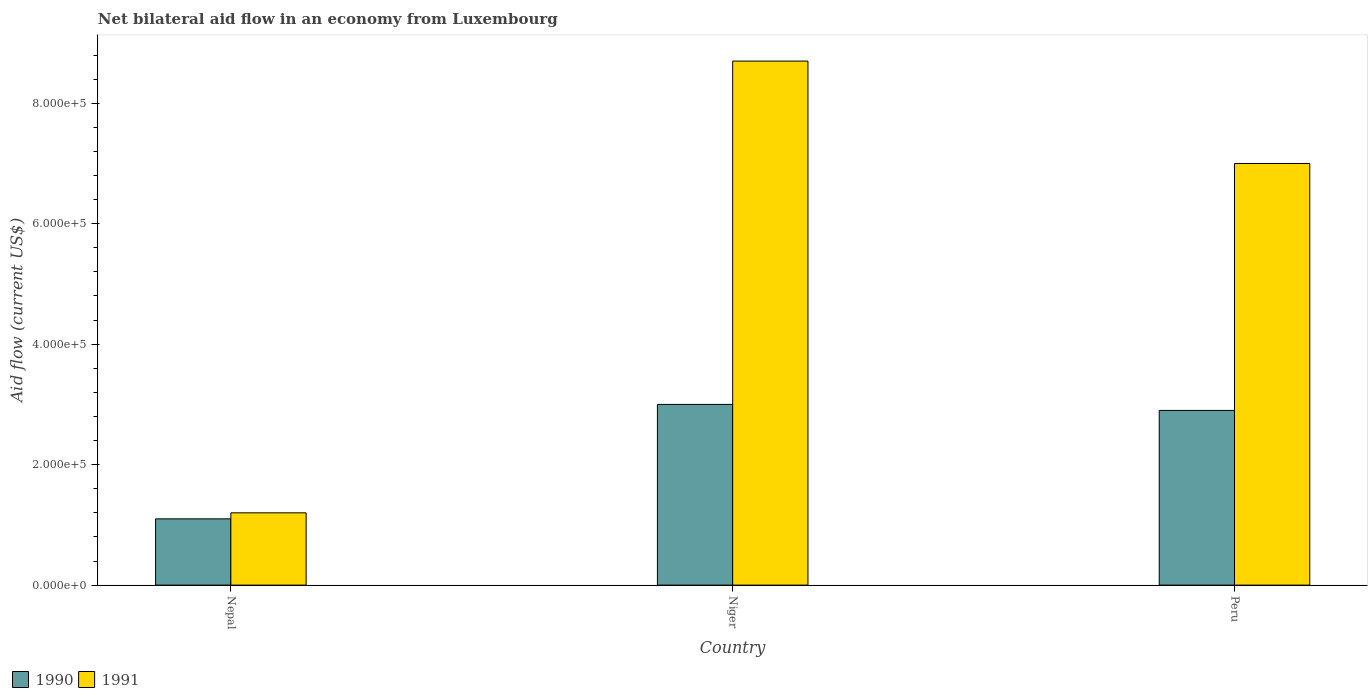How many different coloured bars are there?
Provide a succinct answer. 2. Are the number of bars per tick equal to the number of legend labels?
Give a very brief answer. Yes. How many bars are there on the 1st tick from the left?
Offer a terse response. 2. What is the label of the 2nd group of bars from the left?
Make the answer very short. Niger. What is the net bilateral aid flow in 1991 in Niger?
Keep it short and to the point. 8.70e+05. Across all countries, what is the maximum net bilateral aid flow in 1991?
Make the answer very short. 8.70e+05. Across all countries, what is the minimum net bilateral aid flow in 1991?
Your answer should be very brief. 1.20e+05. In which country was the net bilateral aid flow in 1991 maximum?
Ensure brevity in your answer.  Niger. In which country was the net bilateral aid flow in 1990 minimum?
Offer a very short reply. Nepal. What is the total net bilateral aid flow in 1991 in the graph?
Offer a terse response. 1.69e+06. What is the average net bilateral aid flow in 1990 per country?
Your response must be concise. 2.33e+05. What is the difference between the net bilateral aid flow of/in 1991 and net bilateral aid flow of/in 1990 in Peru?
Offer a terse response. 4.10e+05. What is the ratio of the net bilateral aid flow in 1990 in Nepal to that in Niger?
Keep it short and to the point. 0.37. Is the net bilateral aid flow in 1991 in Niger less than that in Peru?
Give a very brief answer. No. Is the difference between the net bilateral aid flow in 1991 in Nepal and Peru greater than the difference between the net bilateral aid flow in 1990 in Nepal and Peru?
Make the answer very short. No. What is the difference between the highest and the second highest net bilateral aid flow in 1990?
Provide a succinct answer. 1.90e+05. What is the difference between the highest and the lowest net bilateral aid flow in 1991?
Ensure brevity in your answer.  7.50e+05. Is the sum of the net bilateral aid flow in 1990 in Nepal and Niger greater than the maximum net bilateral aid flow in 1991 across all countries?
Offer a terse response. No. How many bars are there?
Ensure brevity in your answer.  6. Are all the bars in the graph horizontal?
Provide a short and direct response. No. How many countries are there in the graph?
Give a very brief answer. 3. What is the difference between two consecutive major ticks on the Y-axis?
Offer a terse response. 2.00e+05. Does the graph contain any zero values?
Your answer should be compact. No. Does the graph contain grids?
Ensure brevity in your answer.  No. What is the title of the graph?
Provide a short and direct response. Net bilateral aid flow in an economy from Luxembourg. What is the label or title of the Y-axis?
Provide a succinct answer. Aid flow (current US$). What is the Aid flow (current US$) in 1990 in Nepal?
Offer a terse response. 1.10e+05. What is the Aid flow (current US$) in 1991 in Nepal?
Your answer should be very brief. 1.20e+05. What is the Aid flow (current US$) of 1990 in Niger?
Give a very brief answer. 3.00e+05. What is the Aid flow (current US$) of 1991 in Niger?
Your answer should be compact. 8.70e+05. What is the Aid flow (current US$) of 1991 in Peru?
Your answer should be very brief. 7.00e+05. Across all countries, what is the maximum Aid flow (current US$) in 1991?
Keep it short and to the point. 8.70e+05. Across all countries, what is the minimum Aid flow (current US$) in 1990?
Keep it short and to the point. 1.10e+05. What is the total Aid flow (current US$) of 1991 in the graph?
Your answer should be very brief. 1.69e+06. What is the difference between the Aid flow (current US$) of 1991 in Nepal and that in Niger?
Provide a short and direct response. -7.50e+05. What is the difference between the Aid flow (current US$) in 1991 in Nepal and that in Peru?
Provide a short and direct response. -5.80e+05. What is the difference between the Aid flow (current US$) of 1990 in Niger and that in Peru?
Your answer should be compact. 10000. What is the difference between the Aid flow (current US$) of 1990 in Nepal and the Aid flow (current US$) of 1991 in Niger?
Your response must be concise. -7.60e+05. What is the difference between the Aid flow (current US$) of 1990 in Nepal and the Aid flow (current US$) of 1991 in Peru?
Keep it short and to the point. -5.90e+05. What is the difference between the Aid flow (current US$) in 1990 in Niger and the Aid flow (current US$) in 1991 in Peru?
Offer a terse response. -4.00e+05. What is the average Aid flow (current US$) of 1990 per country?
Offer a very short reply. 2.33e+05. What is the average Aid flow (current US$) of 1991 per country?
Offer a very short reply. 5.63e+05. What is the difference between the Aid flow (current US$) of 1990 and Aid flow (current US$) of 1991 in Niger?
Your answer should be compact. -5.70e+05. What is the difference between the Aid flow (current US$) of 1990 and Aid flow (current US$) of 1991 in Peru?
Offer a terse response. -4.10e+05. What is the ratio of the Aid flow (current US$) of 1990 in Nepal to that in Niger?
Your answer should be compact. 0.37. What is the ratio of the Aid flow (current US$) of 1991 in Nepal to that in Niger?
Your response must be concise. 0.14. What is the ratio of the Aid flow (current US$) in 1990 in Nepal to that in Peru?
Make the answer very short. 0.38. What is the ratio of the Aid flow (current US$) in 1991 in Nepal to that in Peru?
Offer a terse response. 0.17. What is the ratio of the Aid flow (current US$) in 1990 in Niger to that in Peru?
Ensure brevity in your answer.  1.03. What is the ratio of the Aid flow (current US$) of 1991 in Niger to that in Peru?
Your answer should be very brief. 1.24. What is the difference between the highest and the second highest Aid flow (current US$) in 1991?
Offer a terse response. 1.70e+05. What is the difference between the highest and the lowest Aid flow (current US$) of 1990?
Offer a very short reply. 1.90e+05. What is the difference between the highest and the lowest Aid flow (current US$) in 1991?
Your answer should be very brief. 7.50e+05. 